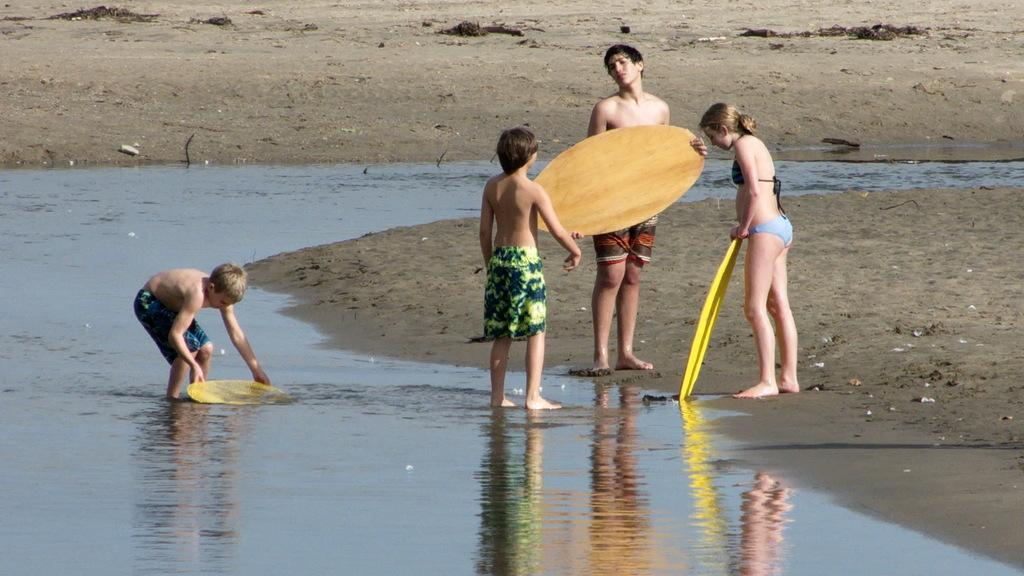What is happening in the middle of the image? There are persons in the middle of the image. What can be seen in the background of the image? There is water visible in the image. What is the man holding in the image? The man is holding a surfing board with his hands. What brand of toothpaste is being used by the persons in the image? There is no toothpaste present in the image. What type of nerve can be seen in the image? There are no nerves visible in the image. 